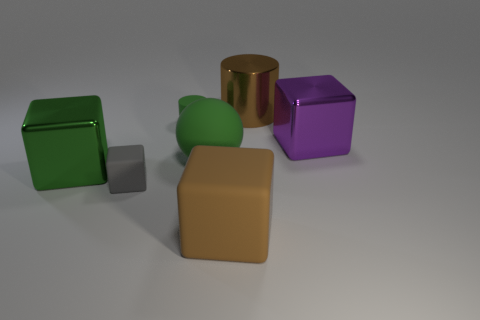Is there any other thing that is the same shape as the large green matte thing?
Offer a very short reply. No. Does the purple shiny block have the same size as the matte cylinder?
Give a very brief answer. No. What material is the green object that is to the right of the small cylinder?
Ensure brevity in your answer.  Rubber. What material is the gray object that is the same shape as the big brown matte thing?
Your response must be concise. Rubber. Is there a big purple block in front of the large brown object that is in front of the large brown metallic thing?
Your answer should be very brief. No. Is the big brown rubber thing the same shape as the big green metallic thing?
Give a very brief answer. Yes. There is a large green object that is the same material as the small cube; what shape is it?
Keep it short and to the point. Sphere. There is a brown object that is behind the large purple object; is its size the same as the green matte object that is on the left side of the large ball?
Your answer should be compact. No. Are there more green metal blocks that are right of the green ball than small gray rubber cubes that are behind the small gray rubber block?
Provide a short and direct response. No. How many other things are there of the same color as the big matte cube?
Ensure brevity in your answer.  1. 